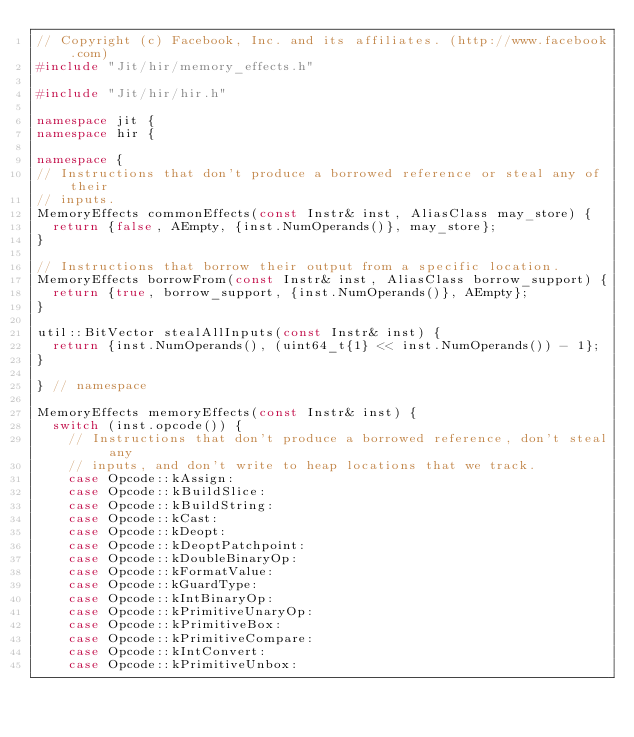<code> <loc_0><loc_0><loc_500><loc_500><_C++_>// Copyright (c) Facebook, Inc. and its affiliates. (http://www.facebook.com)
#include "Jit/hir/memory_effects.h"

#include "Jit/hir/hir.h"

namespace jit {
namespace hir {

namespace {
// Instructions that don't produce a borrowed reference or steal any of their
// inputs.
MemoryEffects commonEffects(const Instr& inst, AliasClass may_store) {
  return {false, AEmpty, {inst.NumOperands()}, may_store};
}

// Instructions that borrow their output from a specific location.
MemoryEffects borrowFrom(const Instr& inst, AliasClass borrow_support) {
  return {true, borrow_support, {inst.NumOperands()}, AEmpty};
}

util::BitVector stealAllInputs(const Instr& inst) {
  return {inst.NumOperands(), (uint64_t{1} << inst.NumOperands()) - 1};
}

} // namespace

MemoryEffects memoryEffects(const Instr& inst) {
  switch (inst.opcode()) {
    // Instructions that don't produce a borrowed reference, don't steal any
    // inputs, and don't write to heap locations that we track.
    case Opcode::kAssign:
    case Opcode::kBuildSlice:
    case Opcode::kBuildString:
    case Opcode::kCast:
    case Opcode::kDeopt:
    case Opcode::kDeoptPatchpoint:
    case Opcode::kDoubleBinaryOp:
    case Opcode::kFormatValue:
    case Opcode::kGuardType:
    case Opcode::kIntBinaryOp:
    case Opcode::kPrimitiveUnaryOp:
    case Opcode::kPrimitiveBox:
    case Opcode::kPrimitiveCompare:
    case Opcode::kIntConvert:
    case Opcode::kPrimitiveUnbox:</code> 